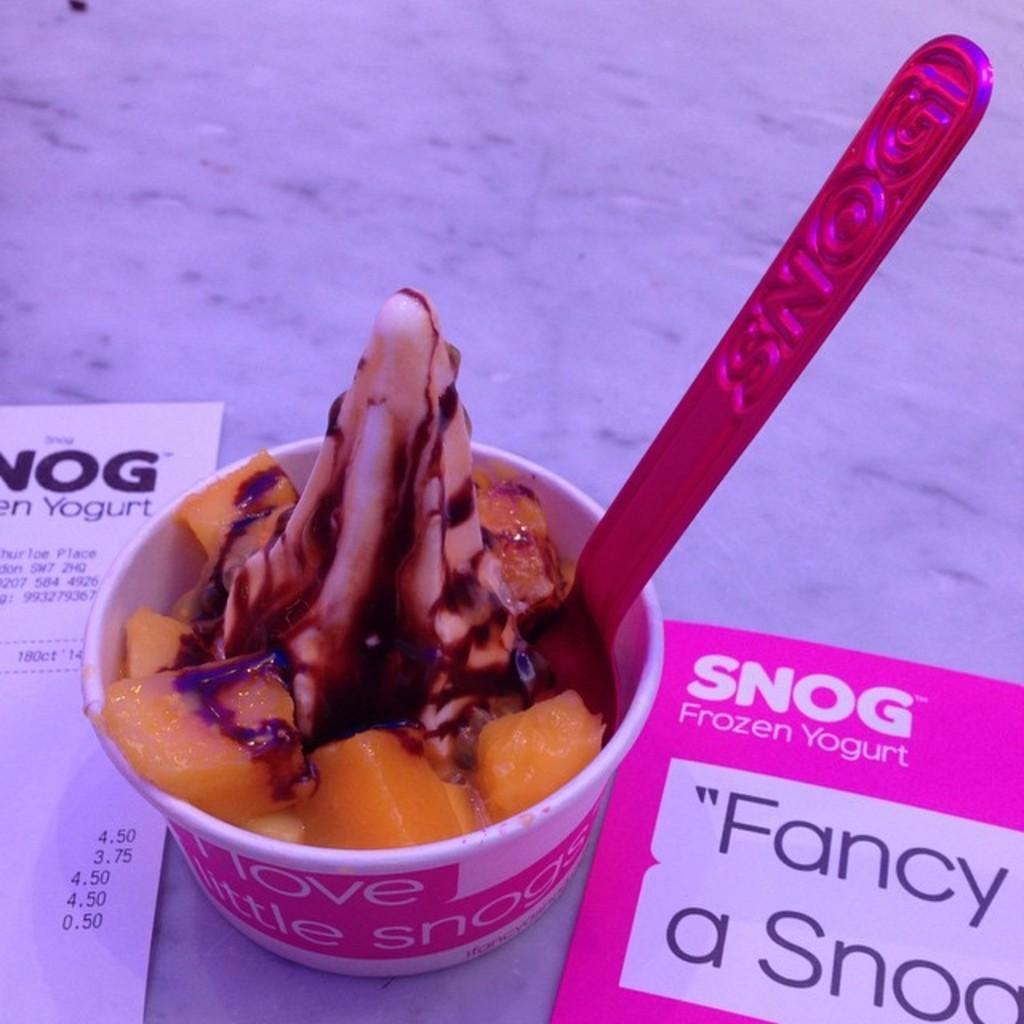Could you give a brief overview of what you see in this image? Here in this picture we can see a table, on which we ice cream cup present with a spoon in it over there and we can also see rate card also present over there. 